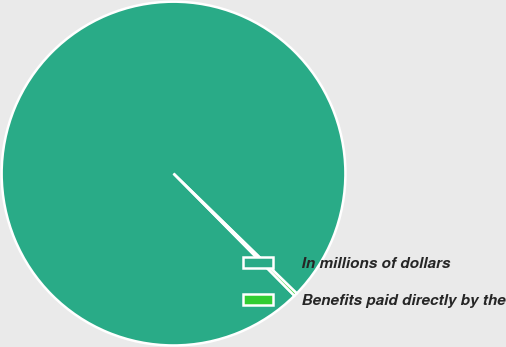Convert chart. <chart><loc_0><loc_0><loc_500><loc_500><pie_chart><fcel>In millions of dollars<fcel>Benefits paid directly by the<nl><fcel>99.7%<fcel>0.3%<nl></chart> 